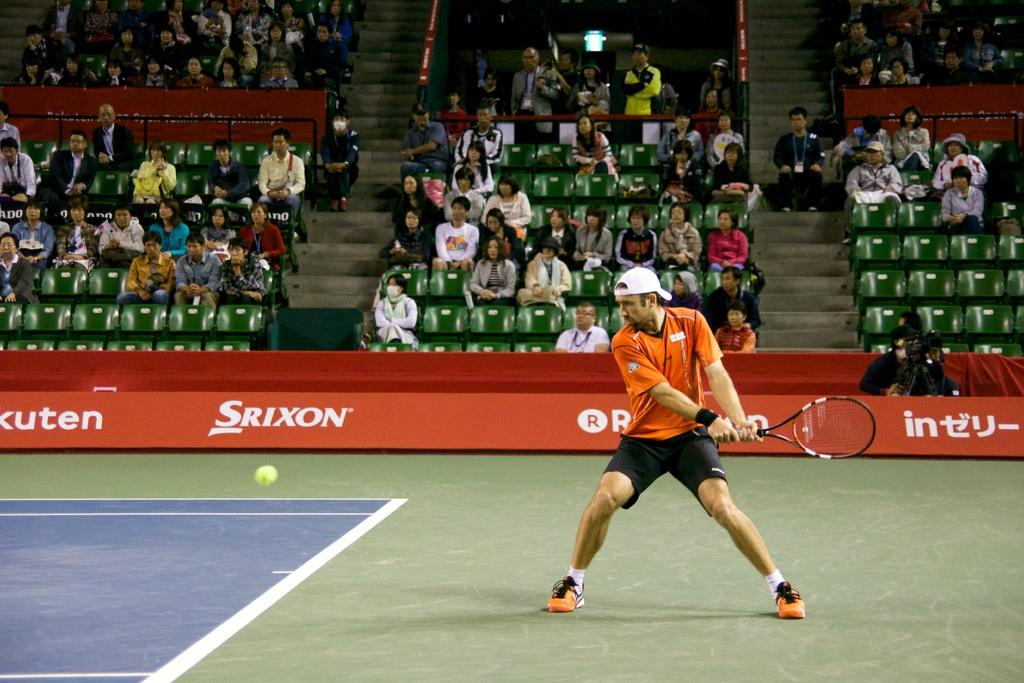<image>
Offer a succinct explanation of the picture presented. Srixon advertises on the perimeter of a tennis court 